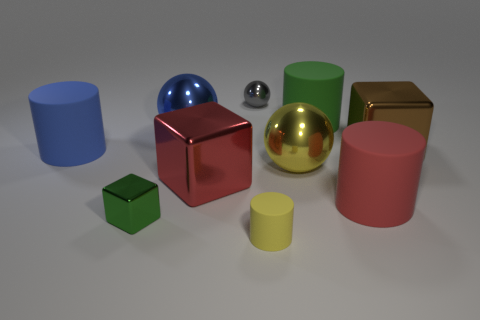Subtract all yellow matte cylinders. How many cylinders are left? 3 Subtract all yellow cylinders. How many cylinders are left? 3 Subtract all brown cylinders. Subtract all purple cubes. How many cylinders are left? 4 Subtract all balls. How many objects are left? 7 Add 5 blue things. How many blue things are left? 7 Add 4 tiny gray metallic things. How many tiny gray metallic things exist? 5 Subtract 1 yellow cylinders. How many objects are left? 9 Subtract all large brown shiny objects. Subtract all big blue cylinders. How many objects are left? 8 